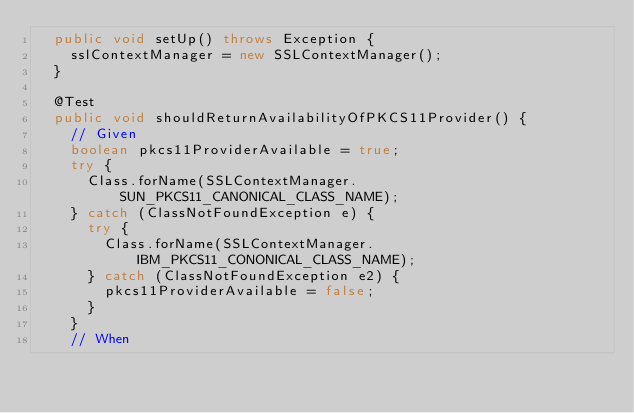<code> <loc_0><loc_0><loc_500><loc_500><_Java_>	public void setUp() throws Exception {
		sslContextManager = new SSLContextManager();
	}

	@Test
	public void shouldReturnAvailabilityOfPKCS11Provider() {
		// Given
		boolean pkcs11ProviderAvailable = true;
		try {
			Class.forName(SSLContextManager.SUN_PKCS11_CANONICAL_CLASS_NAME);
		} catch (ClassNotFoundException e) {
			try {
				Class.forName(SSLContextManager.IBM_PKCS11_CONONICAL_CLASS_NAME);
			} catch (ClassNotFoundException e2) {
				pkcs11ProviderAvailable = false;
			}
		}
		// When</code> 